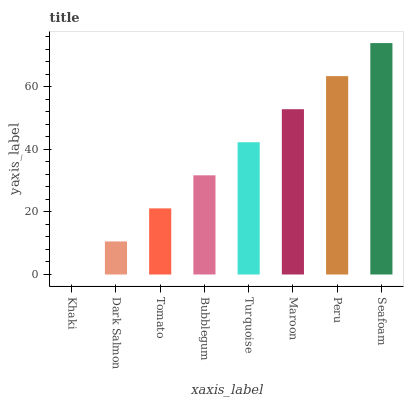Is Khaki the minimum?
Answer yes or no. Yes. Is Seafoam the maximum?
Answer yes or no. Yes. Is Dark Salmon the minimum?
Answer yes or no. No. Is Dark Salmon the maximum?
Answer yes or no. No. Is Dark Salmon greater than Khaki?
Answer yes or no. Yes. Is Khaki less than Dark Salmon?
Answer yes or no. Yes. Is Khaki greater than Dark Salmon?
Answer yes or no. No. Is Dark Salmon less than Khaki?
Answer yes or no. No. Is Turquoise the high median?
Answer yes or no. Yes. Is Bubblegum the low median?
Answer yes or no. Yes. Is Maroon the high median?
Answer yes or no. No. Is Dark Salmon the low median?
Answer yes or no. No. 